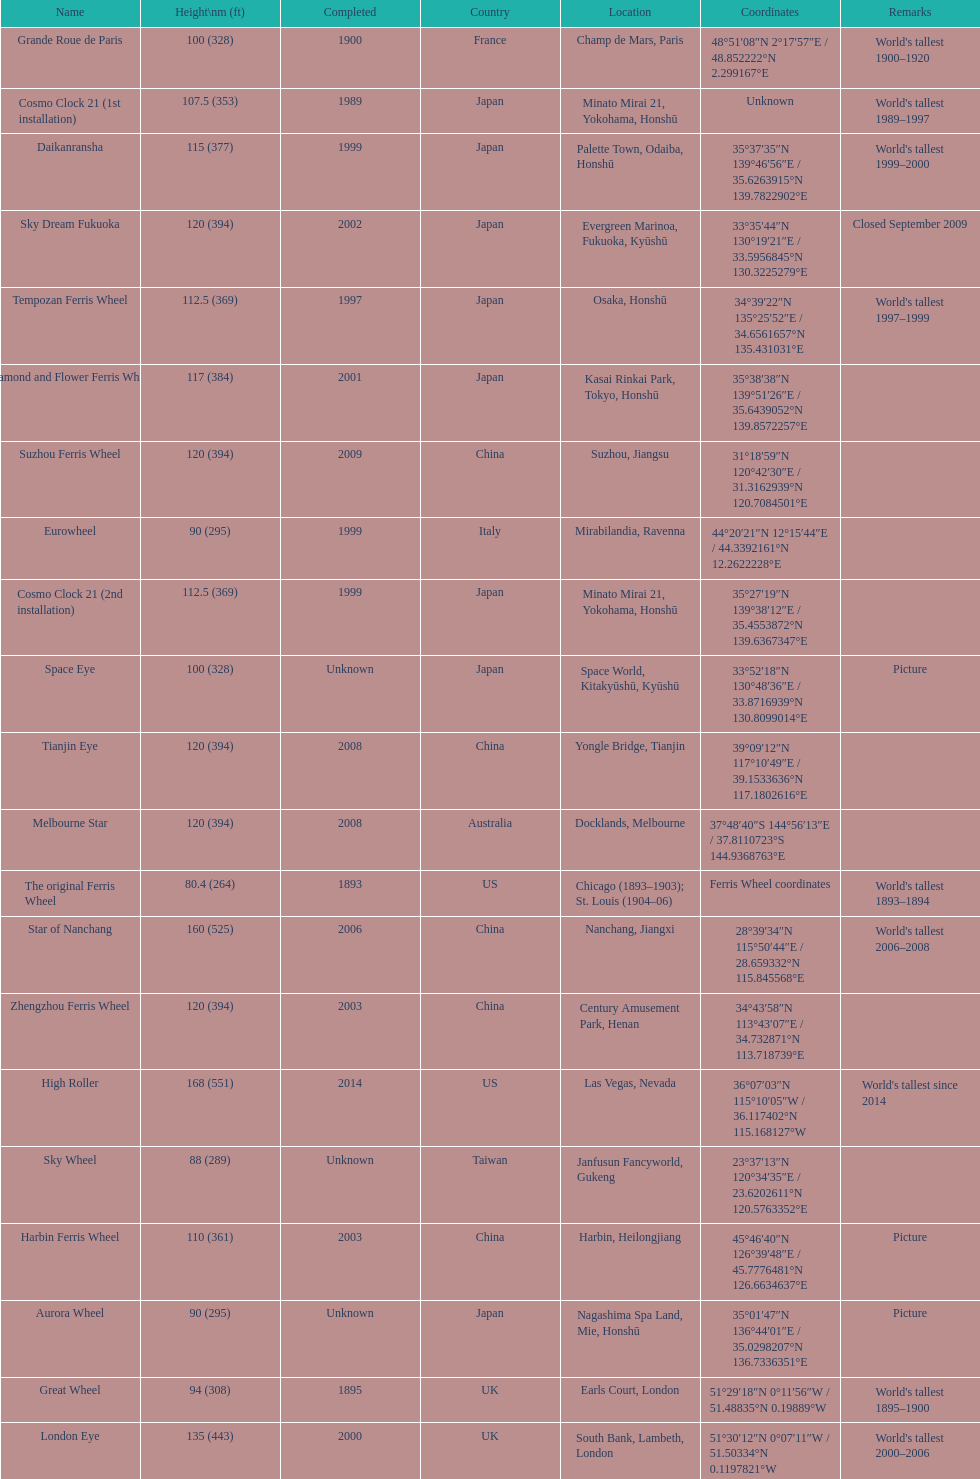Which of the following roller coasters is the oldest: star of lake tai, star of nanchang, melbourne star Star of Nanchang. 